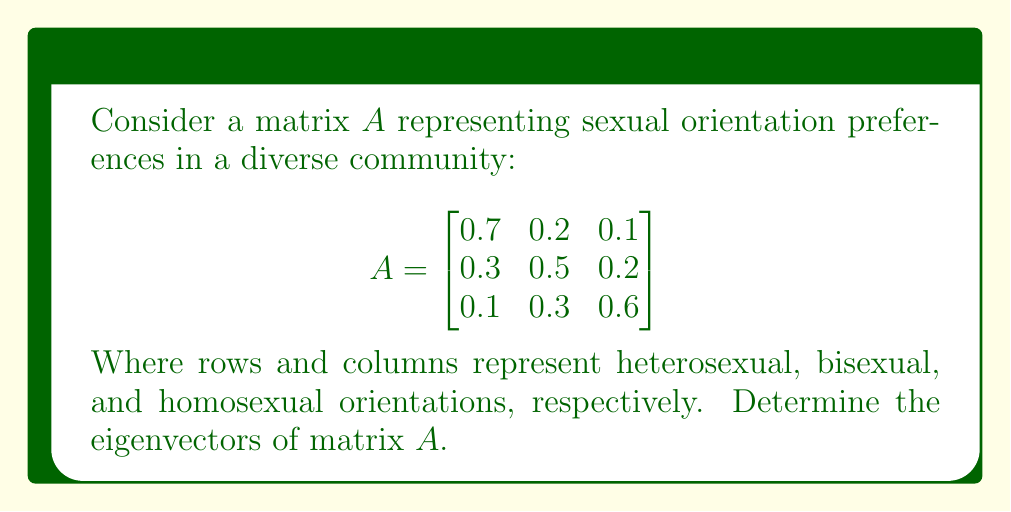Can you answer this question? To find the eigenvectors of matrix $A$, we follow these steps:

1) First, calculate the eigenvalues by solving the characteristic equation:
   $det(A - \lambda I) = 0$

2) Expand the determinant:
   $$\begin{vmatrix}
   0.7-\lambda & 0.2 & 0.1 \\
   0.3 & 0.5-\lambda & 0.2 \\
   0.1 & 0.3 & 0.6-\lambda
   \end{vmatrix} = 0$$

3) Solve the resulting cubic equation:
   $-\lambda^3 + 1.8\lambda^2 - 0.83\lambda + 0.11 = 0$

4) The eigenvalues are: $\lambda_1 = 1$, $\lambda_2 \approx 0.5$, $\lambda_3 \approx 0.3$

5) For each eigenvalue, solve $(A - \lambda I)v = 0$ to find the corresponding eigenvector:

   For $\lambda_1 = 1$:
   $$\begin{bmatrix}
   -0.3 & 0.2 & 0.1 \\
   0.3 & -0.5 & 0.2 \\
   0.1 & 0.3 & -0.4
   \end{bmatrix}\begin{bmatrix}
   v_1 \\ v_2 \\ v_3
   \end{bmatrix} = \begin{bmatrix}
   0 \\ 0 \\ 0
   \end{bmatrix}$$

   Solving this gives us: $v_1 \approx 0.5774$, $v_2 \approx 0.5774$, $v_3 \approx 0.5774$

6) Repeat the process for $\lambda_2$ and $\lambda_3$ to find the other eigenvectors.

7) Normalize each eigenvector to have a magnitude of 1.
Answer: Eigenvectors: $v_1 \approx (0.5774, 0.5774, 0.5774)$, $v_2 \approx (-0.7071, 0, 0.7071)$, $v_3 \approx (-0.4082, 0.8165, -0.4082)$ 